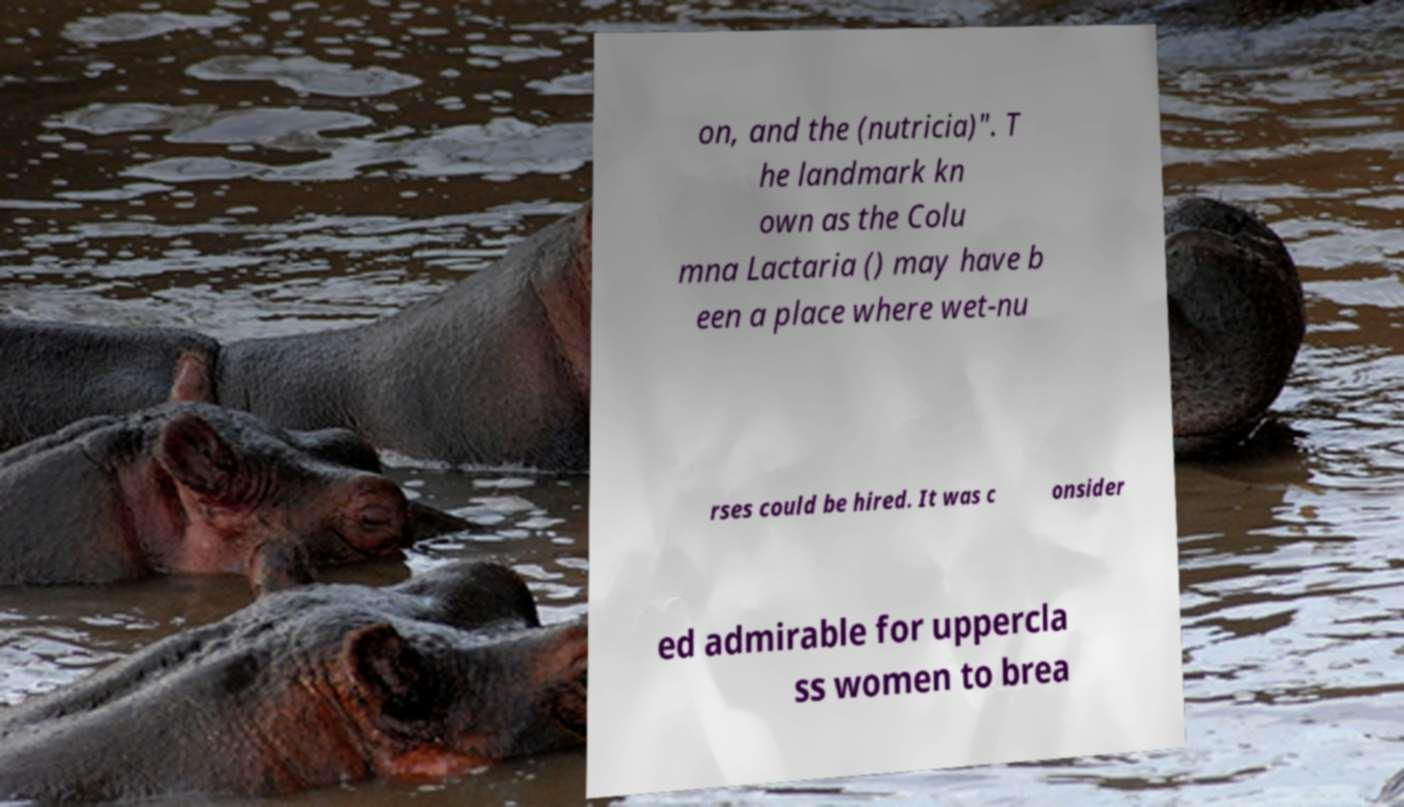Please identify and transcribe the text found in this image. on, and the (nutricia)". T he landmark kn own as the Colu mna Lactaria () may have b een a place where wet-nu rses could be hired. It was c onsider ed admirable for uppercla ss women to brea 